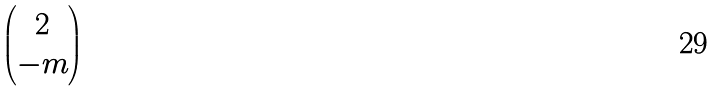Convert formula to latex. <formula><loc_0><loc_0><loc_500><loc_500>\begin{pmatrix} 2 \\ - m \end{pmatrix}</formula> 